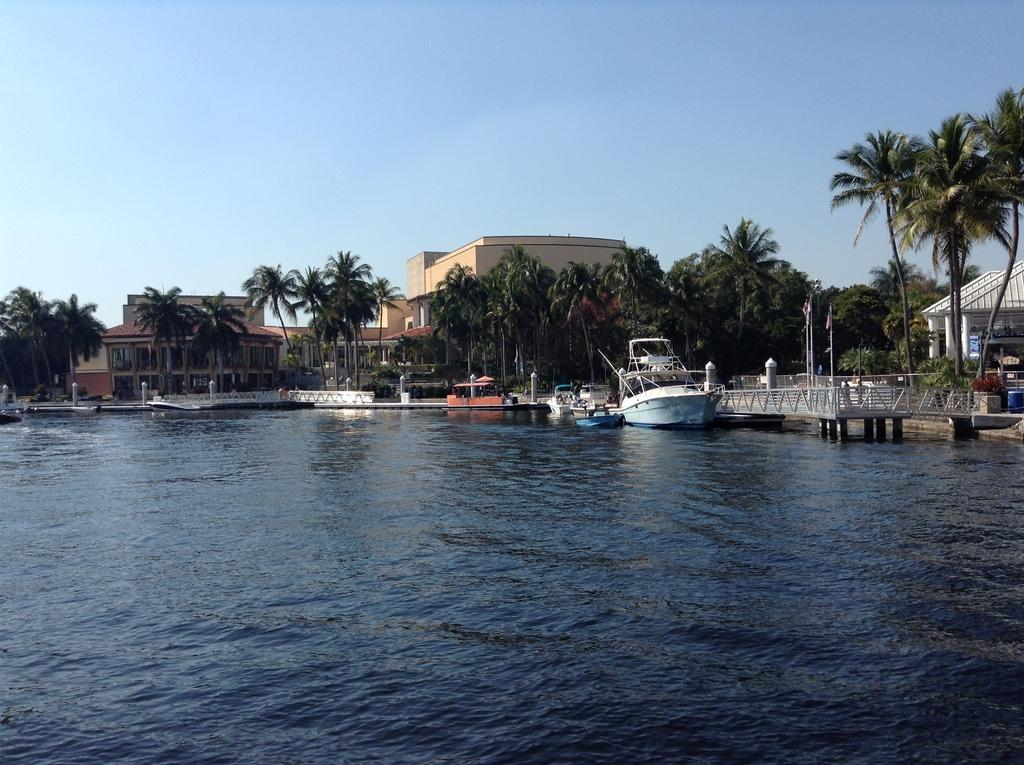What is the primary element in the image? There is water in the image. What is floating on the water? There are boats in the water. What type of vegetation can be seen in the image? There are trees visible in the image. What type of structures are present in the image? There are buildings in the image. What is visible above the water and buildings? The sky is visible in the image. How many pies are being sold by the insect in the image? There is no insect or pies present in the image. 